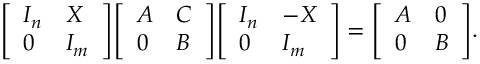<formula> <loc_0><loc_0><loc_500><loc_500>{ \left [ \begin{array} { l l } { I _ { n } } & { X } \\ { 0 } & { I _ { m } } \end{array} \right ] } { \left [ \begin{array} { l l } { A } & { C } \\ { 0 } & { B } \end{array} \right ] } { \left [ \begin{array} { l l } { I _ { n } } & { - X } \\ { 0 } & { I _ { m } } \end{array} \right ] } = { \left [ \begin{array} { l l } { A } & { 0 } \\ { 0 } & { B } \end{array} \right ] } .</formula> 